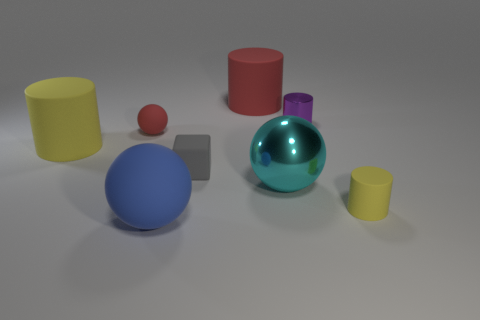Are there any other things that have the same shape as the tiny gray object?
Offer a terse response. No. What is the size of the red object that is the same shape as the blue matte thing?
Your answer should be very brief. Small. Does the cyan object have the same shape as the small red thing?
Offer a very short reply. Yes. Is the number of gray cubes to the right of the gray block less than the number of blocks in front of the big cyan shiny ball?
Give a very brief answer. No. There is a large red cylinder; how many big cylinders are to the left of it?
Keep it short and to the point. 1. There is a big yellow matte object in front of the tiny purple shiny thing; does it have the same shape as the metal thing that is in front of the red ball?
Provide a short and direct response. No. How many other things are the same color as the small ball?
Offer a terse response. 1. What is the material of the red object that is in front of the big cylinder that is right of the rubber ball behind the tiny yellow cylinder?
Your answer should be very brief. Rubber. There is a sphere to the right of the red rubber object behind the red matte ball; what is it made of?
Make the answer very short. Metal. Is the number of big rubber cylinders that are in front of the large cyan thing less than the number of small gray balls?
Your answer should be very brief. No. 